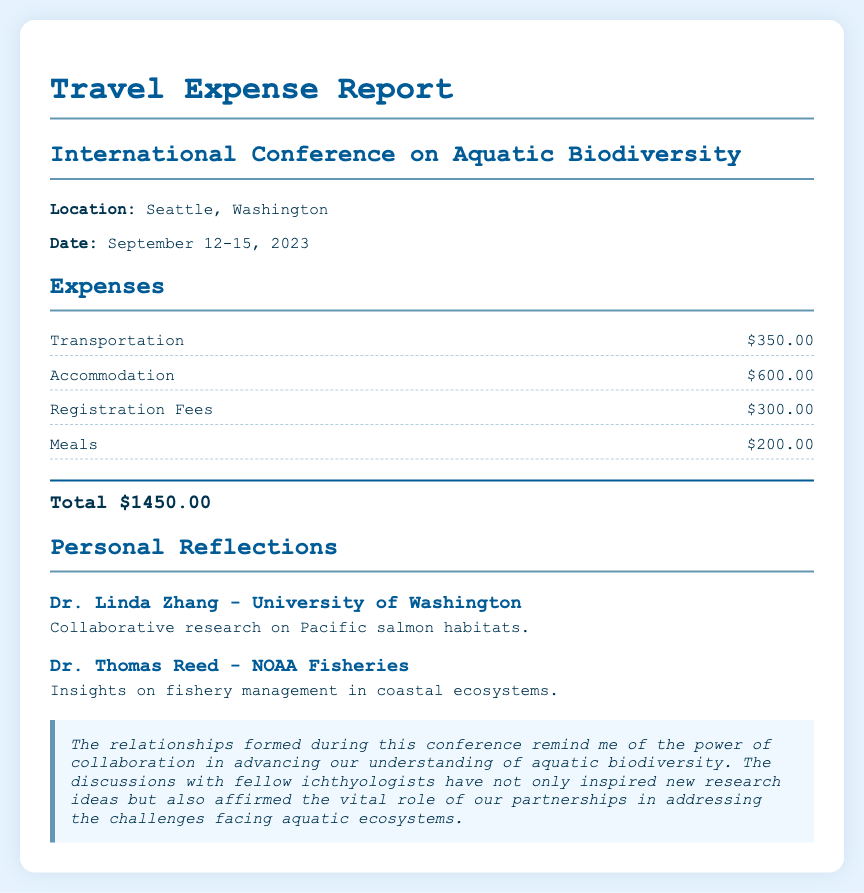What was the total expense for the trip? The total expense is calculated by adding up all individual expenses: Transportation, Accommodation, Registration Fees, and Meals, which totals $1450.00.
Answer: $1450.00 How much was spent on accommodation? The document lists the accommodation expense separately, indicating how much was spent specifically on this category.
Answer: $600.00 Who was collaborating on Pacific salmon habitats? The document mentions specific individuals and their areas of collaboration; one such individual is mentioned in the partnerships section.
Answer: Dr. Linda Zhang What were the registration fees for the conference? The document specifies the registration fees amount as part of the overall expenses.
Answer: $300.00 Which location hosted the conference? The location of the conference is explicitly mentioned at the beginning of the document.
Answer: Seattle, Washington What is the purpose of the personal reflections section? This section reflects on the importance of relationships formed and partnerships in scientific research, showing how attendance at the conference created opportunities for collaboration.
Answer: Partnerships in scientific research How many expenses are listed in the report? The report lists four specific categories of expenses directly related to the trip.
Answer: Four What type of conference was attended? The document specifies the type of conference, indicating the focus or theme of the event attended.
Answer: International Conference on Aquatic Biodiversity Who provided insights on fishery management? The document lists individuals along with their contributions, including insights on fishery management from one representative mentioned.
Answer: Dr. Thomas Reed 